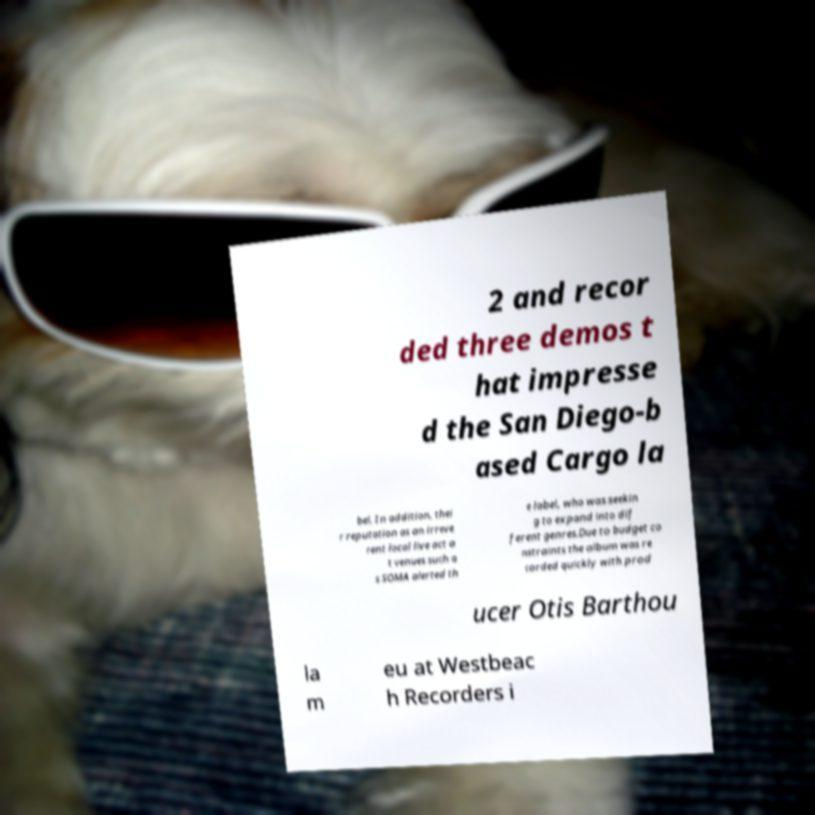What messages or text are displayed in this image? I need them in a readable, typed format. 2 and recor ded three demos t hat impresse d the San Diego-b ased Cargo la bel. In addition, thei r reputation as an irreve rent local live act a t venues such a s SOMA alerted th e label, who was seekin g to expand into dif ferent genres.Due to budget co nstraints the album was re corded quickly with prod ucer Otis Barthou la m eu at Westbeac h Recorders i 